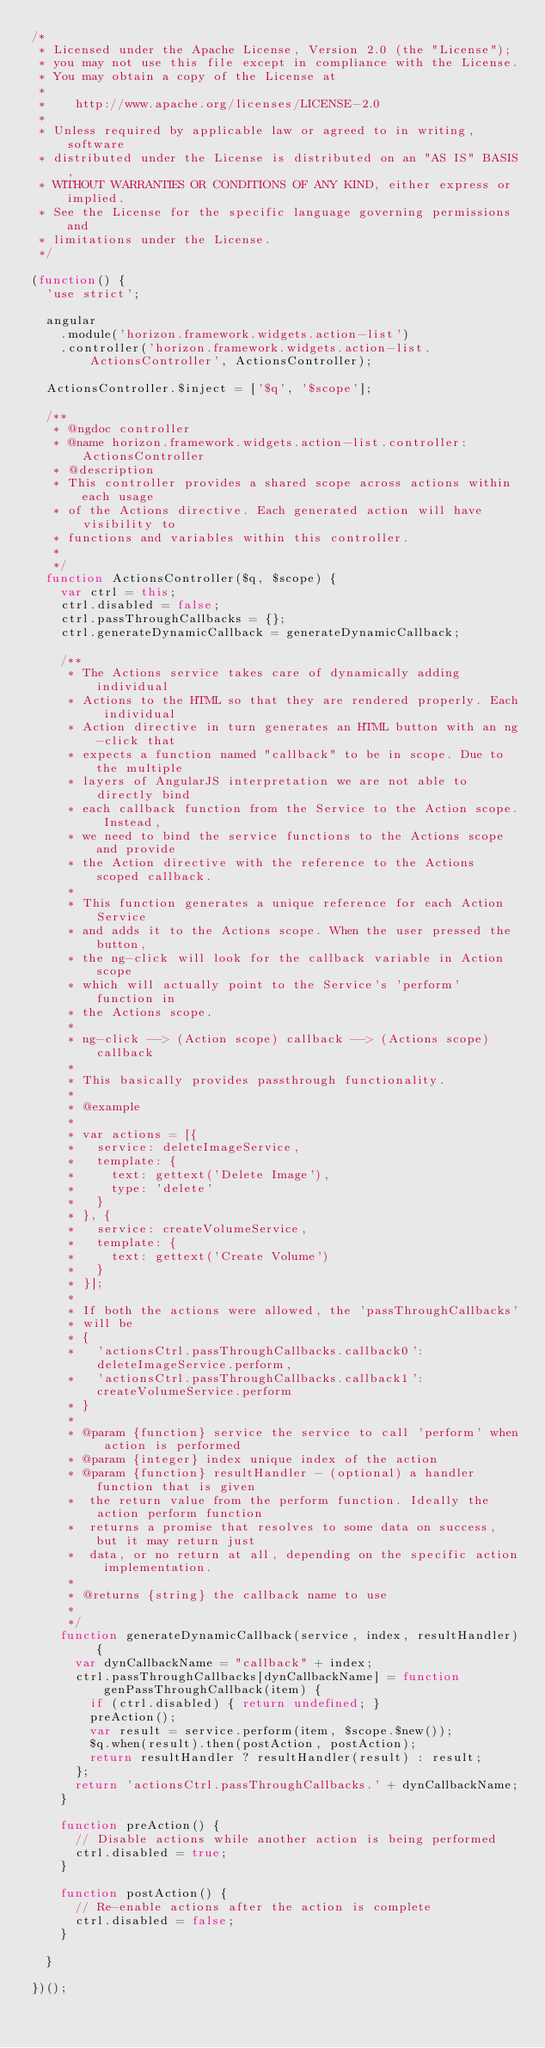<code> <loc_0><loc_0><loc_500><loc_500><_JavaScript_>/*
 * Licensed under the Apache License, Version 2.0 (the "License");
 * you may not use this file except in compliance with the License.
 * You may obtain a copy of the License at
 *
 *    http://www.apache.org/licenses/LICENSE-2.0
 *
 * Unless required by applicable law or agreed to in writing, software
 * distributed under the License is distributed on an "AS IS" BASIS,
 * WITHOUT WARRANTIES OR CONDITIONS OF ANY KIND, either express or implied.
 * See the License for the specific language governing permissions and
 * limitations under the License.
 */

(function() {
  'use strict';

  angular
    .module('horizon.framework.widgets.action-list')
    .controller('horizon.framework.widgets.action-list.ActionsController', ActionsController);

  ActionsController.$inject = ['$q', '$scope'];

  /**
   * @ngdoc controller
   * @name horizon.framework.widgets.action-list.controller:ActionsController
   * @description
   * This controller provides a shared scope across actions within each usage
   * of the Actions directive. Each generated action will have visibility to
   * functions and variables within this controller.
   *
   */
  function ActionsController($q, $scope) {
    var ctrl = this;
    ctrl.disabled = false;
    ctrl.passThroughCallbacks = {};
    ctrl.generateDynamicCallback = generateDynamicCallback;

    /**
     * The Actions service takes care of dynamically adding individual
     * Actions to the HTML so that they are rendered properly. Each individual
     * Action directive in turn generates an HTML button with an ng-click that
     * expects a function named "callback" to be in scope. Due to the multiple
     * layers of AngularJS interpretation we are not able to directly bind
     * each callback function from the Service to the Action scope. Instead,
     * we need to bind the service functions to the Actions scope and provide
     * the Action directive with the reference to the Actions scoped callback.
     *
     * This function generates a unique reference for each Action Service
     * and adds it to the Actions scope. When the user pressed the button,
     * the ng-click will look for the callback variable in Action scope
     * which will actually point to the Service's 'perform' function in
     * the Actions scope.
     *
     * ng-click --> (Action scope) callback --> (Actions scope) callback
     *
     * This basically provides passthrough functionality.
     *
     * @example
     *
     * var actions = [{
     *   service: deleteImageService,
     *   template: {
     *     text: gettext('Delete Image'),
     *     type: 'delete'
     *   }
     * }, {
     *   service: createVolumeService,
     *   template: {
     *     text: gettext('Create Volume')
     *   }
     * }];
     *
     * If both the actions were allowed, the 'passThroughCallbacks'
     * will be
     * {
     *   'actionsCtrl.passThroughCallbacks.callback0': deleteImageService.perform,
     *   'actionsCtrl.passThroughCallbacks.callback1': createVolumeService.perform
     * }
     *
     * @param {function} service the service to call 'perform' when action is performed
     * @param {integer} index unique index of the action
     * @param {function} resultHandler - (optional) a handler function that is given
     *  the return value from the perform function. Ideally the action perform function
     *  returns a promise that resolves to some data on success, but it may return just
     *  data, or no return at all, depending on the specific action implementation.
     *
     * @returns {string} the callback name to use
     *
     */
    function generateDynamicCallback(service, index, resultHandler) {
      var dynCallbackName = "callback" + index;
      ctrl.passThroughCallbacks[dynCallbackName] = function genPassThroughCallback(item) {
        if (ctrl.disabled) { return undefined; }
        preAction();
        var result = service.perform(item, $scope.$new());
        $q.when(result).then(postAction, postAction);
        return resultHandler ? resultHandler(result) : result;
      };
      return 'actionsCtrl.passThroughCallbacks.' + dynCallbackName;
    }

    function preAction() {
      // Disable actions while another action is being performed
      ctrl.disabled = true;
    }

    function postAction() {
      // Re-enable actions after the action is complete
      ctrl.disabled = false;
    }

  }

})();
</code> 